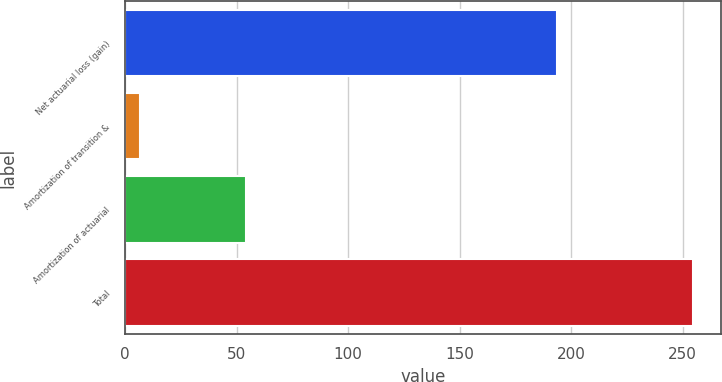<chart> <loc_0><loc_0><loc_500><loc_500><bar_chart><fcel>Net actuarial loss (gain)<fcel>Amortization of transition &<fcel>Amortization of actuarial<fcel>Total<nl><fcel>193.7<fcel>6.7<fcel>54<fcel>254.4<nl></chart> 